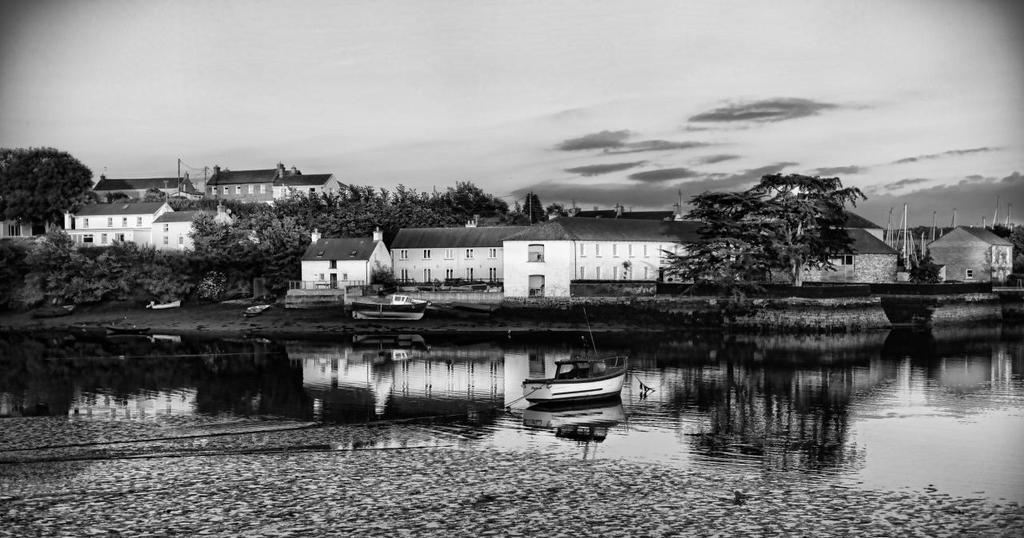Can you describe this image briefly? In this image we can see black and white picture of a group of buildings with windows and roofs, poles, group of trees. In the foreground we can see boats in the water. In the background, we can see the cloudy sky. 